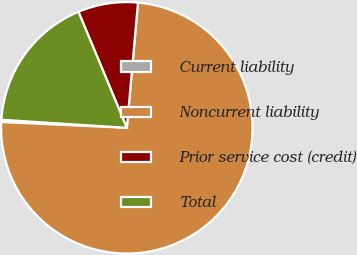<chart> <loc_0><loc_0><loc_500><loc_500><pie_chart><fcel>Current liability<fcel>Noncurrent liability<fcel>Prior service cost (credit)<fcel>Total<nl><fcel>0.29%<fcel>74.32%<fcel>7.7%<fcel>17.69%<nl></chart> 